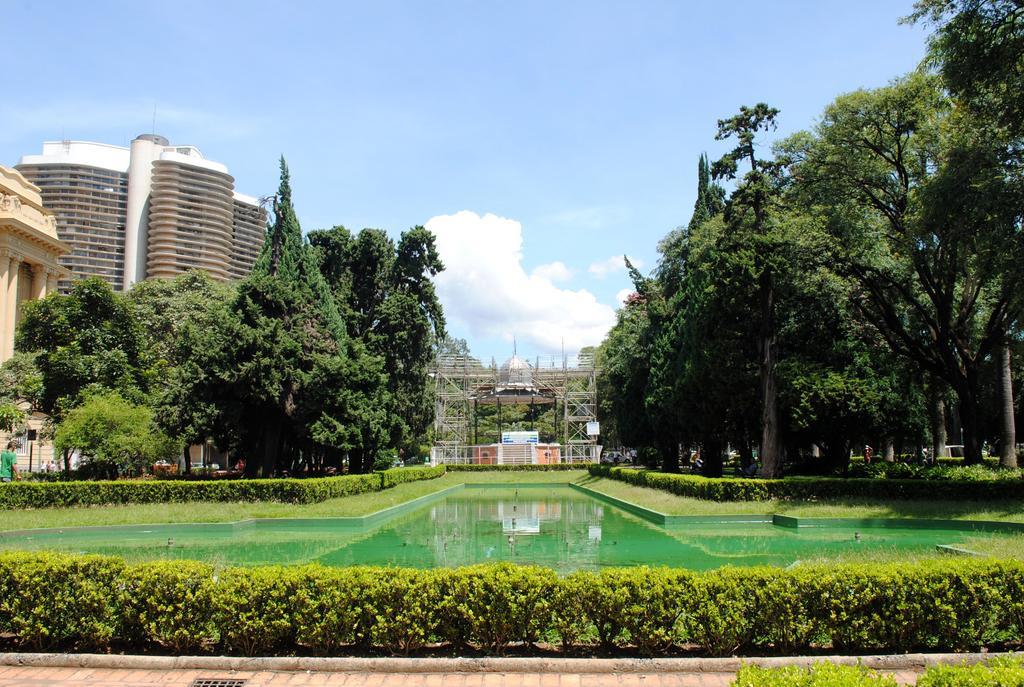Can you describe this image briefly? In this image we can see there are buildings, trees, plants and water. In the background we can see cloudy sky. 